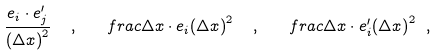Convert formula to latex. <formula><loc_0><loc_0><loc_500><loc_500>\frac { e _ { i } \cdot e ^ { \prime } _ { j } } { { ( \Delta x ) } ^ { 2 } } \ \ , \ \ \ f r a c { \Delta x \cdot e _ { i } } { { ( \Delta x ) } ^ { 2 } } \ \ , \ \ \ f r a c { \Delta x \cdot e ^ { \prime } _ { i } } { { ( \Delta x ) } ^ { 2 } } \ ,</formula> 